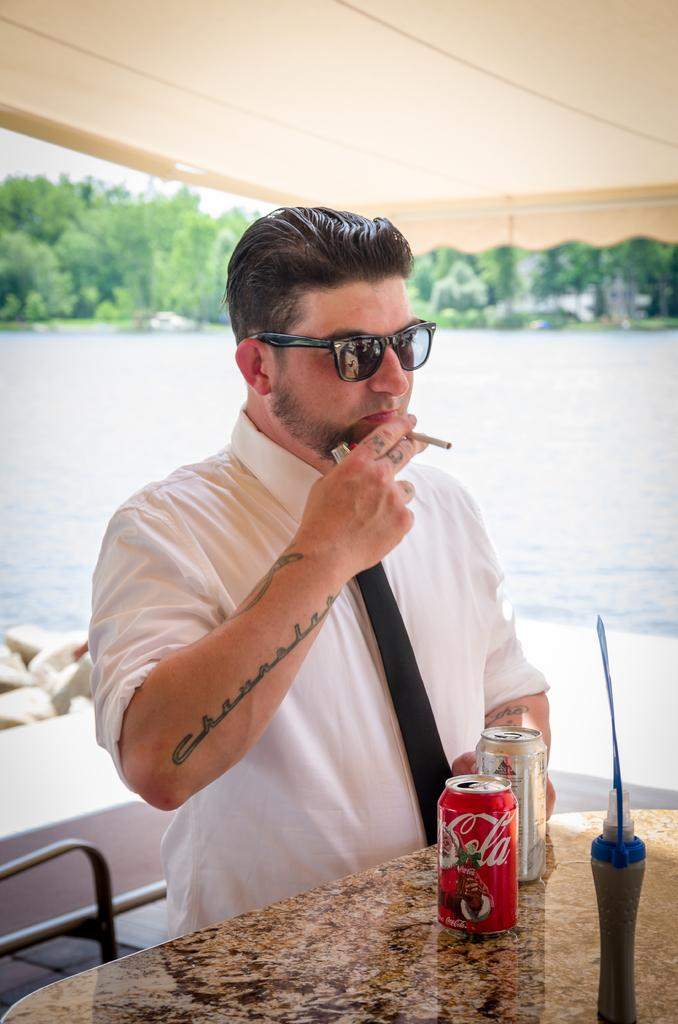What can be seen in the image? There is a person in the image. Can you describe the person's attire? The person is wearing a white shirt and goggles. What is the person holding in the image? The person is holding a cigar. What type of water body is depicted in the image? The image depicts a freshwater river. What can be seen in the distance? There are trees visible in the distance. What objects are present on the table in the image? There are tins and a bottle on a table in the image. What flavor of ray can be seen swimming in the river in the image? There are no rays present in the image, and the image does not depict any sea creatures. 